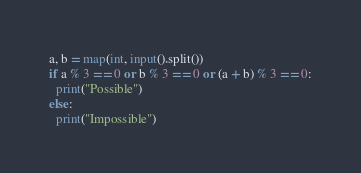Convert code to text. <code><loc_0><loc_0><loc_500><loc_500><_Python_>a, b = map(int, input().split())
if a % 3 == 0 or b % 3 == 0 or (a + b) % 3 == 0:
  print("Possible")
else:
  print("Impossible")</code> 